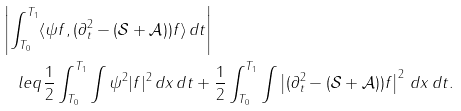<formula> <loc_0><loc_0><loc_500><loc_500>& \left | \int _ { T _ { 0 } } ^ { T _ { 1 } } \langle \psi f , ( \partial _ { t } ^ { 2 } - ( \mathcal { S } + \mathcal { A } ) ) f \rangle \, d t \right | \\ & \ \ \ l e q \frac { 1 } { 2 } \int _ { T _ { 0 } } ^ { T _ { 1 } } \int \psi ^ { 2 } | f | ^ { 2 } \, d x \, d t + \frac { 1 } { 2 } \int _ { T _ { 0 } } ^ { T _ { 1 } } \int \left | ( \partial _ { t } ^ { 2 } - ( \mathcal { S } + \mathcal { A } ) ) f \right | ^ { 2 } \, d x \, d t .</formula> 